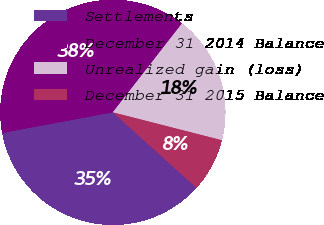Convert chart. <chart><loc_0><loc_0><loc_500><loc_500><pie_chart><fcel>Settlements<fcel>December 31 2014 Balance<fcel>Unrealized gain (loss)<fcel>December 31 2015 Balance<nl><fcel>35.38%<fcel>38.46%<fcel>18.46%<fcel>7.69%<nl></chart> 